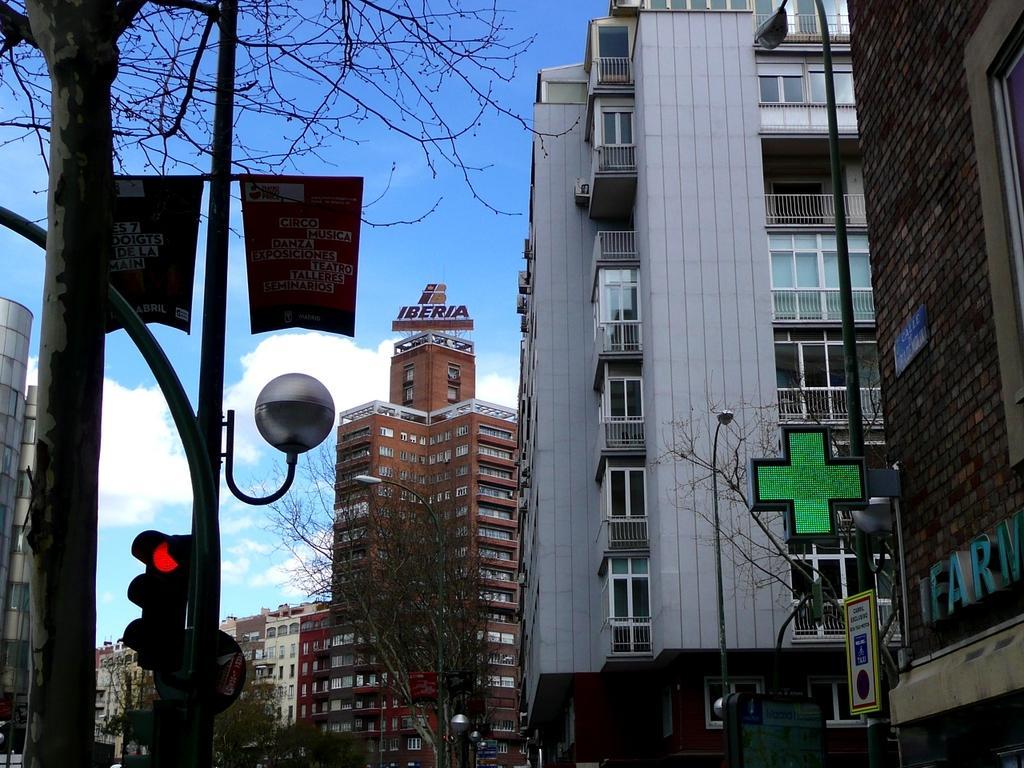Describe this image in one or two sentences. In the image there are a lot of buildings, in front of the buildings there are trees, street lights and there is a traffic signal pole on the left side. Beside that there is a tree. 